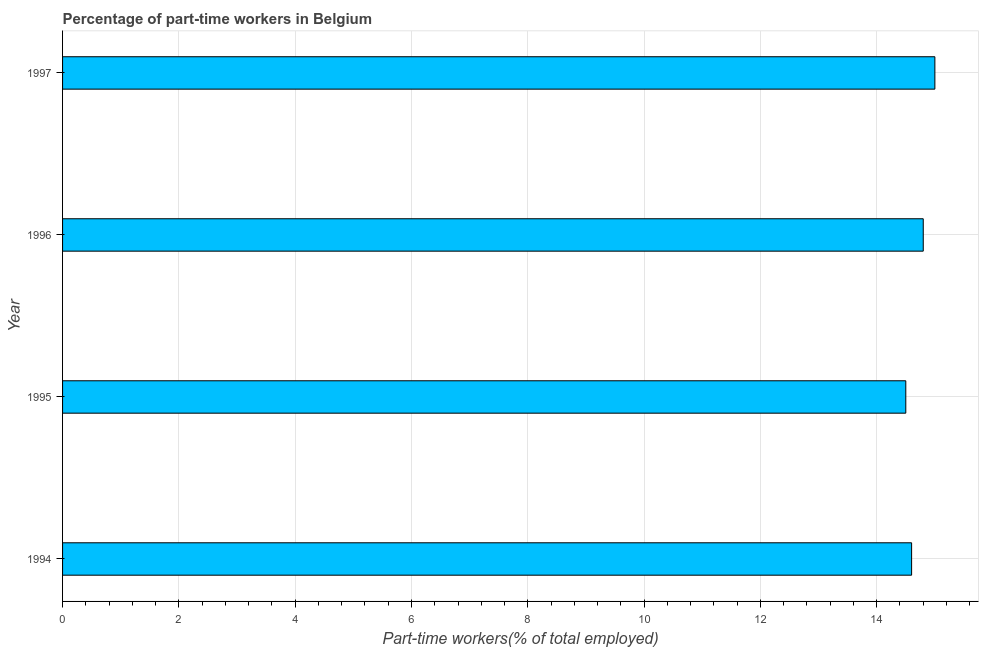Does the graph contain any zero values?
Provide a succinct answer. No. What is the title of the graph?
Keep it short and to the point. Percentage of part-time workers in Belgium. What is the label or title of the X-axis?
Offer a terse response. Part-time workers(% of total employed). Across all years, what is the maximum percentage of part-time workers?
Offer a very short reply. 15. Across all years, what is the minimum percentage of part-time workers?
Keep it short and to the point. 14.5. In which year was the percentage of part-time workers maximum?
Your answer should be very brief. 1997. In which year was the percentage of part-time workers minimum?
Provide a short and direct response. 1995. What is the sum of the percentage of part-time workers?
Offer a very short reply. 58.9. What is the average percentage of part-time workers per year?
Offer a terse response. 14.72. What is the median percentage of part-time workers?
Your response must be concise. 14.7. Is the difference between the percentage of part-time workers in 1994 and 1996 greater than the difference between any two years?
Provide a short and direct response. No. What is the difference between the highest and the second highest percentage of part-time workers?
Offer a terse response. 0.2. What is the difference between the highest and the lowest percentage of part-time workers?
Provide a succinct answer. 0.5. How many bars are there?
Your answer should be compact. 4. Are all the bars in the graph horizontal?
Provide a short and direct response. Yes. What is the difference between two consecutive major ticks on the X-axis?
Make the answer very short. 2. What is the Part-time workers(% of total employed) of 1994?
Ensure brevity in your answer.  14.6. What is the Part-time workers(% of total employed) in 1996?
Keep it short and to the point. 14.8. What is the difference between the Part-time workers(% of total employed) in 1994 and 1996?
Your answer should be compact. -0.2. What is the difference between the Part-time workers(% of total employed) in 1994 and 1997?
Give a very brief answer. -0.4. What is the difference between the Part-time workers(% of total employed) in 1995 and 1997?
Provide a succinct answer. -0.5. What is the ratio of the Part-time workers(% of total employed) in 1994 to that in 1997?
Give a very brief answer. 0.97. What is the ratio of the Part-time workers(% of total employed) in 1995 to that in 1997?
Make the answer very short. 0.97. 